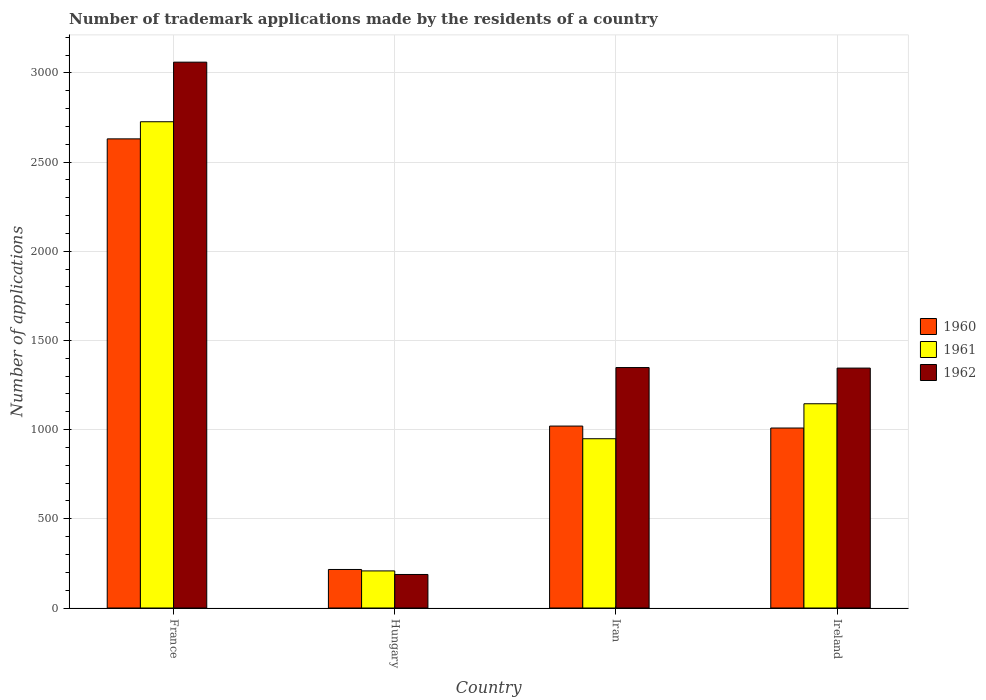How many different coloured bars are there?
Your response must be concise. 3. How many groups of bars are there?
Ensure brevity in your answer.  4. Are the number of bars per tick equal to the number of legend labels?
Provide a short and direct response. Yes. Are the number of bars on each tick of the X-axis equal?
Your response must be concise. Yes. How many bars are there on the 3rd tick from the left?
Provide a succinct answer. 3. What is the label of the 3rd group of bars from the left?
Offer a terse response. Iran. In how many cases, is the number of bars for a given country not equal to the number of legend labels?
Your answer should be very brief. 0. What is the number of trademark applications made by the residents in 1960 in France?
Your answer should be compact. 2630. Across all countries, what is the maximum number of trademark applications made by the residents in 1961?
Give a very brief answer. 2726. Across all countries, what is the minimum number of trademark applications made by the residents in 1961?
Provide a succinct answer. 208. In which country was the number of trademark applications made by the residents in 1962 minimum?
Give a very brief answer. Hungary. What is the total number of trademark applications made by the residents in 1962 in the graph?
Provide a short and direct response. 5941. What is the difference between the number of trademark applications made by the residents in 1960 in France and that in Iran?
Offer a terse response. 1610. What is the difference between the number of trademark applications made by the residents in 1962 in France and the number of trademark applications made by the residents in 1961 in Iran?
Provide a short and direct response. 2111. What is the average number of trademark applications made by the residents in 1961 per country?
Make the answer very short. 1257. What is the difference between the number of trademark applications made by the residents of/in 1962 and number of trademark applications made by the residents of/in 1961 in Iran?
Your answer should be very brief. 399. In how many countries, is the number of trademark applications made by the residents in 1961 greater than 1900?
Offer a terse response. 1. What is the ratio of the number of trademark applications made by the residents in 1962 in Hungary to that in Iran?
Your response must be concise. 0.14. Is the difference between the number of trademark applications made by the residents in 1962 in Iran and Ireland greater than the difference between the number of trademark applications made by the residents in 1961 in Iran and Ireland?
Give a very brief answer. Yes. What is the difference between the highest and the second highest number of trademark applications made by the residents in 1960?
Your answer should be compact. -11. What is the difference between the highest and the lowest number of trademark applications made by the residents in 1961?
Your response must be concise. 2518. Is the sum of the number of trademark applications made by the residents in 1960 in Hungary and Ireland greater than the maximum number of trademark applications made by the residents in 1961 across all countries?
Keep it short and to the point. No. What does the 2nd bar from the left in France represents?
Offer a very short reply. 1961. Is it the case that in every country, the sum of the number of trademark applications made by the residents in 1962 and number of trademark applications made by the residents in 1961 is greater than the number of trademark applications made by the residents in 1960?
Offer a very short reply. Yes. Are all the bars in the graph horizontal?
Provide a short and direct response. No. How many countries are there in the graph?
Keep it short and to the point. 4. Are the values on the major ticks of Y-axis written in scientific E-notation?
Provide a succinct answer. No. Does the graph contain any zero values?
Provide a short and direct response. No. Does the graph contain grids?
Your answer should be very brief. Yes. How many legend labels are there?
Offer a terse response. 3. How are the legend labels stacked?
Give a very brief answer. Vertical. What is the title of the graph?
Ensure brevity in your answer.  Number of trademark applications made by the residents of a country. What is the label or title of the X-axis?
Your answer should be very brief. Country. What is the label or title of the Y-axis?
Give a very brief answer. Number of applications. What is the Number of applications of 1960 in France?
Ensure brevity in your answer.  2630. What is the Number of applications of 1961 in France?
Your answer should be compact. 2726. What is the Number of applications of 1962 in France?
Provide a short and direct response. 3060. What is the Number of applications in 1960 in Hungary?
Offer a terse response. 216. What is the Number of applications of 1961 in Hungary?
Your response must be concise. 208. What is the Number of applications of 1962 in Hungary?
Provide a succinct answer. 188. What is the Number of applications in 1960 in Iran?
Offer a terse response. 1020. What is the Number of applications in 1961 in Iran?
Your response must be concise. 949. What is the Number of applications of 1962 in Iran?
Your answer should be very brief. 1348. What is the Number of applications in 1960 in Ireland?
Keep it short and to the point. 1009. What is the Number of applications in 1961 in Ireland?
Offer a terse response. 1145. What is the Number of applications of 1962 in Ireland?
Keep it short and to the point. 1345. Across all countries, what is the maximum Number of applications of 1960?
Ensure brevity in your answer.  2630. Across all countries, what is the maximum Number of applications in 1961?
Your answer should be compact. 2726. Across all countries, what is the maximum Number of applications of 1962?
Your answer should be very brief. 3060. Across all countries, what is the minimum Number of applications of 1960?
Your answer should be very brief. 216. Across all countries, what is the minimum Number of applications in 1961?
Give a very brief answer. 208. Across all countries, what is the minimum Number of applications of 1962?
Give a very brief answer. 188. What is the total Number of applications of 1960 in the graph?
Ensure brevity in your answer.  4875. What is the total Number of applications of 1961 in the graph?
Offer a very short reply. 5028. What is the total Number of applications in 1962 in the graph?
Give a very brief answer. 5941. What is the difference between the Number of applications of 1960 in France and that in Hungary?
Your answer should be very brief. 2414. What is the difference between the Number of applications of 1961 in France and that in Hungary?
Give a very brief answer. 2518. What is the difference between the Number of applications of 1962 in France and that in Hungary?
Give a very brief answer. 2872. What is the difference between the Number of applications in 1960 in France and that in Iran?
Your answer should be compact. 1610. What is the difference between the Number of applications of 1961 in France and that in Iran?
Provide a short and direct response. 1777. What is the difference between the Number of applications in 1962 in France and that in Iran?
Give a very brief answer. 1712. What is the difference between the Number of applications of 1960 in France and that in Ireland?
Offer a terse response. 1621. What is the difference between the Number of applications of 1961 in France and that in Ireland?
Your response must be concise. 1581. What is the difference between the Number of applications of 1962 in France and that in Ireland?
Your answer should be compact. 1715. What is the difference between the Number of applications of 1960 in Hungary and that in Iran?
Keep it short and to the point. -804. What is the difference between the Number of applications in 1961 in Hungary and that in Iran?
Make the answer very short. -741. What is the difference between the Number of applications in 1962 in Hungary and that in Iran?
Offer a very short reply. -1160. What is the difference between the Number of applications of 1960 in Hungary and that in Ireland?
Make the answer very short. -793. What is the difference between the Number of applications in 1961 in Hungary and that in Ireland?
Provide a succinct answer. -937. What is the difference between the Number of applications of 1962 in Hungary and that in Ireland?
Your response must be concise. -1157. What is the difference between the Number of applications in 1960 in Iran and that in Ireland?
Give a very brief answer. 11. What is the difference between the Number of applications in 1961 in Iran and that in Ireland?
Offer a terse response. -196. What is the difference between the Number of applications in 1960 in France and the Number of applications in 1961 in Hungary?
Keep it short and to the point. 2422. What is the difference between the Number of applications of 1960 in France and the Number of applications of 1962 in Hungary?
Your answer should be compact. 2442. What is the difference between the Number of applications in 1961 in France and the Number of applications in 1962 in Hungary?
Your answer should be compact. 2538. What is the difference between the Number of applications of 1960 in France and the Number of applications of 1961 in Iran?
Offer a very short reply. 1681. What is the difference between the Number of applications of 1960 in France and the Number of applications of 1962 in Iran?
Offer a terse response. 1282. What is the difference between the Number of applications in 1961 in France and the Number of applications in 1962 in Iran?
Your answer should be compact. 1378. What is the difference between the Number of applications in 1960 in France and the Number of applications in 1961 in Ireland?
Your answer should be compact. 1485. What is the difference between the Number of applications in 1960 in France and the Number of applications in 1962 in Ireland?
Your answer should be very brief. 1285. What is the difference between the Number of applications in 1961 in France and the Number of applications in 1962 in Ireland?
Ensure brevity in your answer.  1381. What is the difference between the Number of applications of 1960 in Hungary and the Number of applications of 1961 in Iran?
Your answer should be compact. -733. What is the difference between the Number of applications of 1960 in Hungary and the Number of applications of 1962 in Iran?
Offer a very short reply. -1132. What is the difference between the Number of applications of 1961 in Hungary and the Number of applications of 1962 in Iran?
Offer a very short reply. -1140. What is the difference between the Number of applications in 1960 in Hungary and the Number of applications in 1961 in Ireland?
Provide a succinct answer. -929. What is the difference between the Number of applications in 1960 in Hungary and the Number of applications in 1962 in Ireland?
Ensure brevity in your answer.  -1129. What is the difference between the Number of applications of 1961 in Hungary and the Number of applications of 1962 in Ireland?
Keep it short and to the point. -1137. What is the difference between the Number of applications in 1960 in Iran and the Number of applications in 1961 in Ireland?
Provide a short and direct response. -125. What is the difference between the Number of applications of 1960 in Iran and the Number of applications of 1962 in Ireland?
Your answer should be compact. -325. What is the difference between the Number of applications of 1961 in Iran and the Number of applications of 1962 in Ireland?
Give a very brief answer. -396. What is the average Number of applications of 1960 per country?
Make the answer very short. 1218.75. What is the average Number of applications of 1961 per country?
Your answer should be compact. 1257. What is the average Number of applications in 1962 per country?
Ensure brevity in your answer.  1485.25. What is the difference between the Number of applications of 1960 and Number of applications of 1961 in France?
Your answer should be compact. -96. What is the difference between the Number of applications in 1960 and Number of applications in 1962 in France?
Provide a short and direct response. -430. What is the difference between the Number of applications in 1961 and Number of applications in 1962 in France?
Keep it short and to the point. -334. What is the difference between the Number of applications of 1961 and Number of applications of 1962 in Hungary?
Keep it short and to the point. 20. What is the difference between the Number of applications of 1960 and Number of applications of 1961 in Iran?
Offer a terse response. 71. What is the difference between the Number of applications of 1960 and Number of applications of 1962 in Iran?
Offer a very short reply. -328. What is the difference between the Number of applications of 1961 and Number of applications of 1962 in Iran?
Provide a short and direct response. -399. What is the difference between the Number of applications of 1960 and Number of applications of 1961 in Ireland?
Offer a very short reply. -136. What is the difference between the Number of applications of 1960 and Number of applications of 1962 in Ireland?
Provide a short and direct response. -336. What is the difference between the Number of applications of 1961 and Number of applications of 1962 in Ireland?
Offer a very short reply. -200. What is the ratio of the Number of applications in 1960 in France to that in Hungary?
Your answer should be very brief. 12.18. What is the ratio of the Number of applications in 1961 in France to that in Hungary?
Make the answer very short. 13.11. What is the ratio of the Number of applications of 1962 in France to that in Hungary?
Offer a very short reply. 16.28. What is the ratio of the Number of applications of 1960 in France to that in Iran?
Your answer should be compact. 2.58. What is the ratio of the Number of applications of 1961 in France to that in Iran?
Make the answer very short. 2.87. What is the ratio of the Number of applications in 1962 in France to that in Iran?
Your answer should be very brief. 2.27. What is the ratio of the Number of applications in 1960 in France to that in Ireland?
Provide a succinct answer. 2.61. What is the ratio of the Number of applications in 1961 in France to that in Ireland?
Ensure brevity in your answer.  2.38. What is the ratio of the Number of applications of 1962 in France to that in Ireland?
Offer a terse response. 2.28. What is the ratio of the Number of applications of 1960 in Hungary to that in Iran?
Your answer should be compact. 0.21. What is the ratio of the Number of applications in 1961 in Hungary to that in Iran?
Ensure brevity in your answer.  0.22. What is the ratio of the Number of applications of 1962 in Hungary to that in Iran?
Your answer should be compact. 0.14. What is the ratio of the Number of applications in 1960 in Hungary to that in Ireland?
Make the answer very short. 0.21. What is the ratio of the Number of applications of 1961 in Hungary to that in Ireland?
Your answer should be very brief. 0.18. What is the ratio of the Number of applications in 1962 in Hungary to that in Ireland?
Offer a very short reply. 0.14. What is the ratio of the Number of applications in 1960 in Iran to that in Ireland?
Provide a succinct answer. 1.01. What is the ratio of the Number of applications in 1961 in Iran to that in Ireland?
Offer a very short reply. 0.83. What is the difference between the highest and the second highest Number of applications in 1960?
Give a very brief answer. 1610. What is the difference between the highest and the second highest Number of applications of 1961?
Keep it short and to the point. 1581. What is the difference between the highest and the second highest Number of applications of 1962?
Provide a short and direct response. 1712. What is the difference between the highest and the lowest Number of applications in 1960?
Ensure brevity in your answer.  2414. What is the difference between the highest and the lowest Number of applications in 1961?
Provide a succinct answer. 2518. What is the difference between the highest and the lowest Number of applications of 1962?
Offer a very short reply. 2872. 